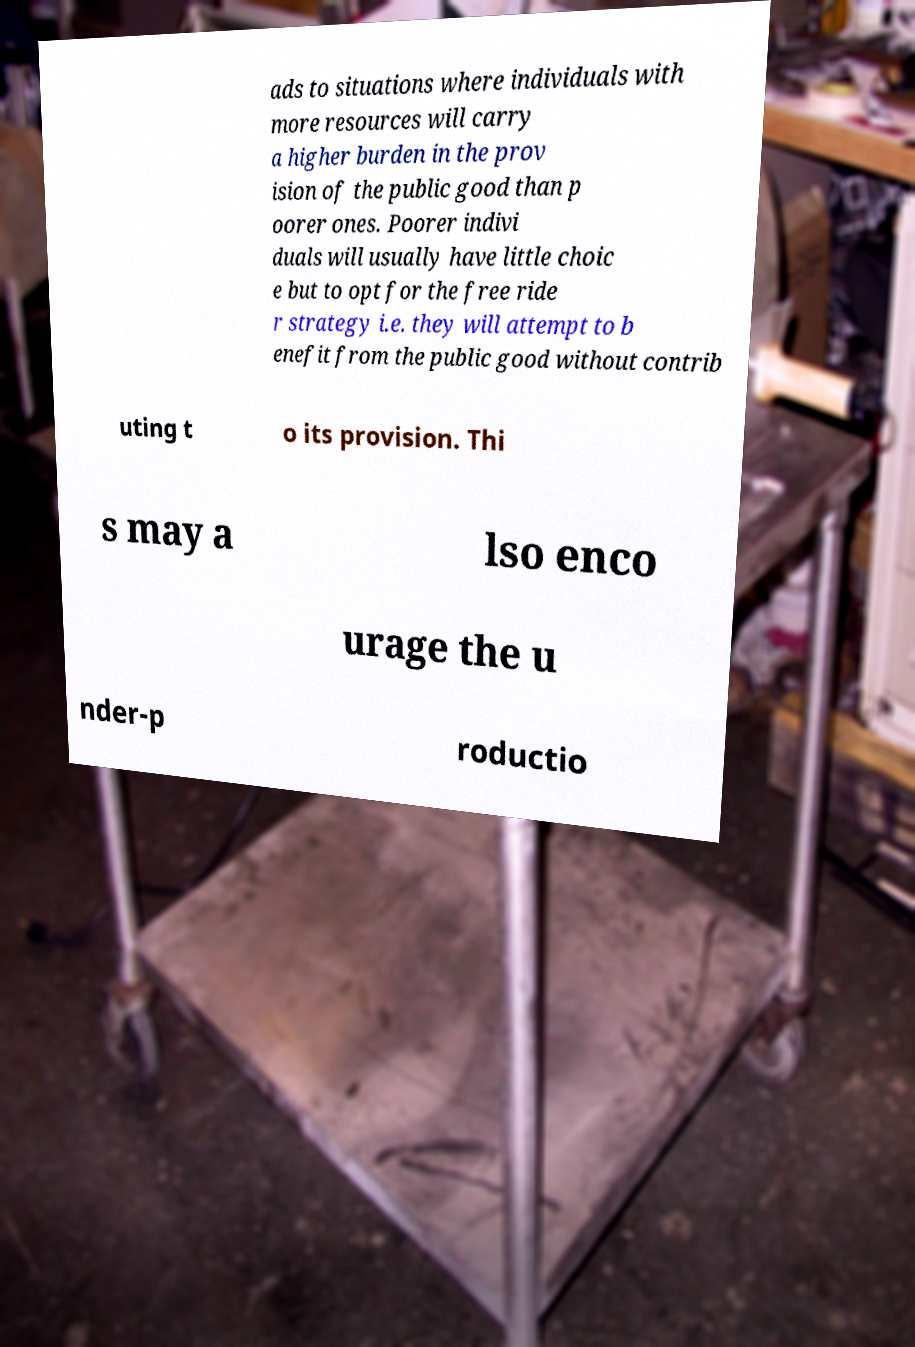Can you accurately transcribe the text from the provided image for me? ads to situations where individuals with more resources will carry a higher burden in the prov ision of the public good than p oorer ones. Poorer indivi duals will usually have little choic e but to opt for the free ride r strategy i.e. they will attempt to b enefit from the public good without contrib uting t o its provision. Thi s may a lso enco urage the u nder-p roductio 